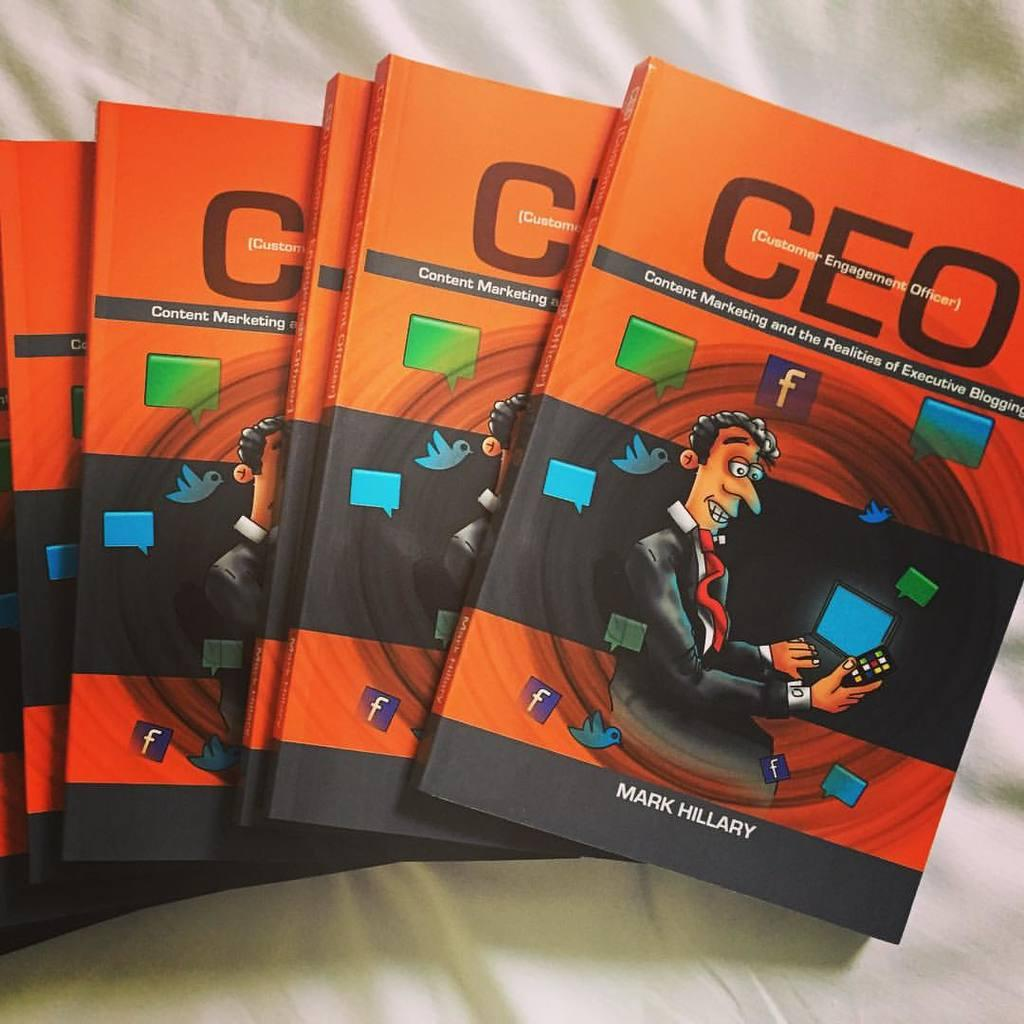Provide a one-sentence caption for the provided image. Multiple copy of the book titled "CEO Content Marketing and the Realities of Executive Blogging". 